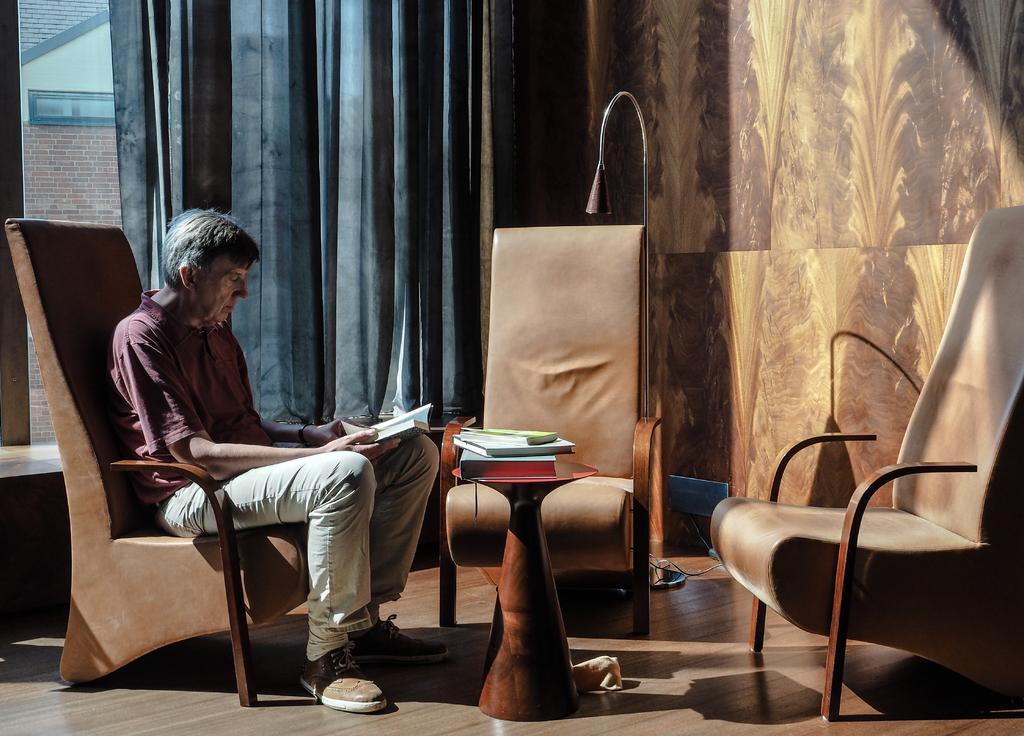How would you summarize this image in a sentence or two? In this image there is a person sitting on the chair and holding a book, and there are books on the table, chairs, curtain,wooden wall, lamp. 